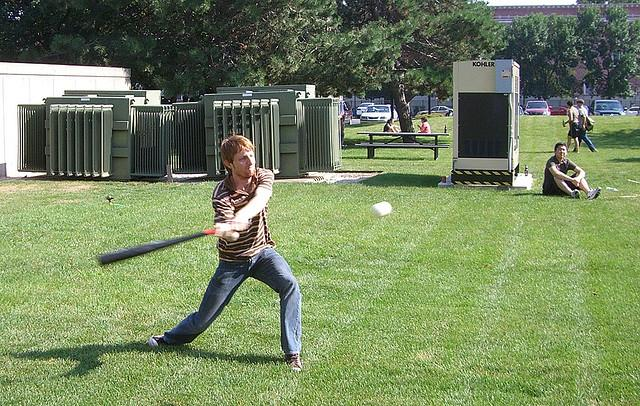What does the unit named Kohler provide? air conditioning 